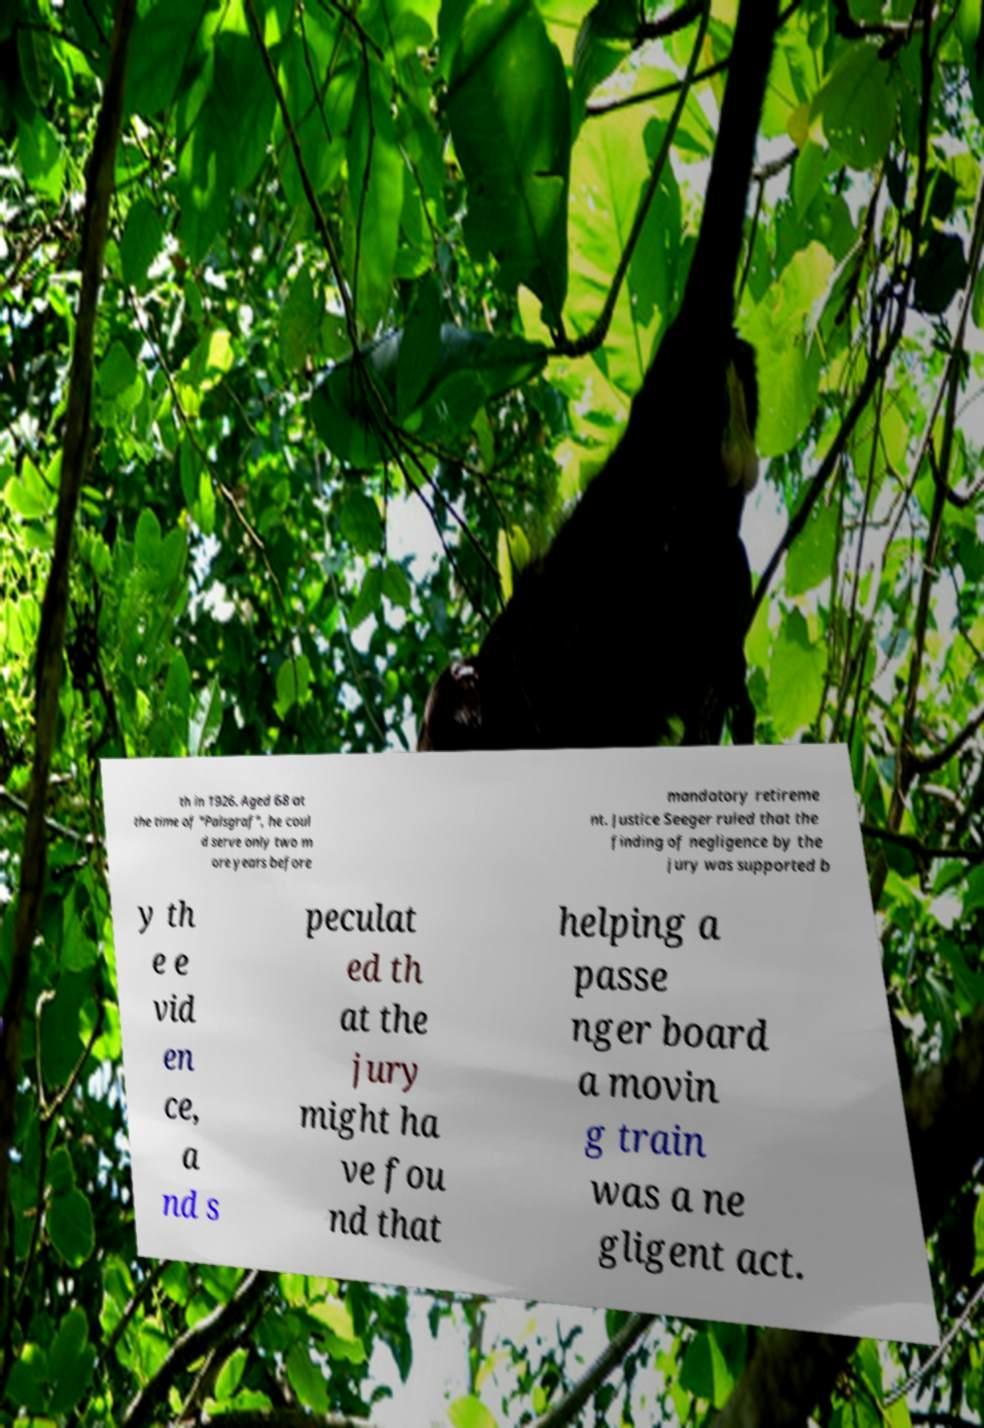Please read and relay the text visible in this image. What does it say? th in 1926. Aged 68 at the time of "Palsgraf", he coul d serve only two m ore years before mandatory retireme nt. Justice Seeger ruled that the finding of negligence by the jury was supported b y th e e vid en ce, a nd s peculat ed th at the jury might ha ve fou nd that helping a passe nger board a movin g train was a ne gligent act. 